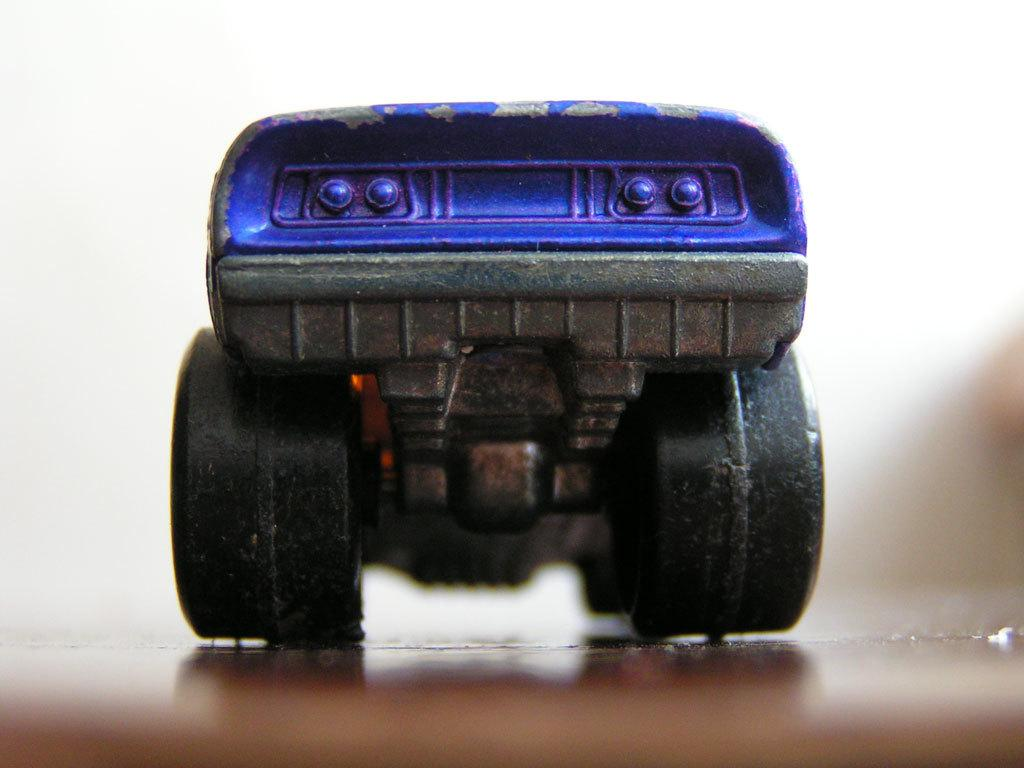What color is the toy in the image? The toy in the image is blue. What part of a vehicle or toy might have black tires? Black tires are typically found on vehicles or toys that have wheels, such as cars or bicycles. What key is used to play the toy in the image? The image does not show a toy that requires a key to play. 